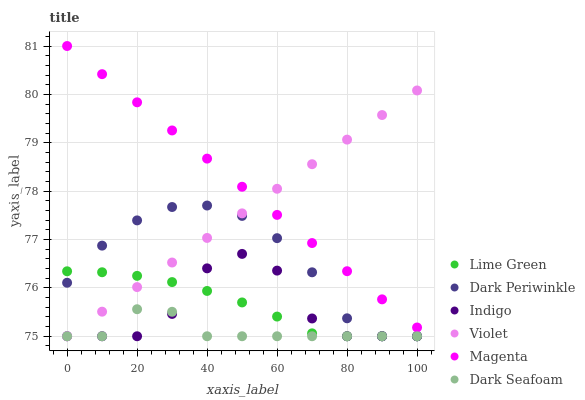Does Dark Seafoam have the minimum area under the curve?
Answer yes or no. Yes. Does Magenta have the maximum area under the curve?
Answer yes or no. Yes. Does Violet have the minimum area under the curve?
Answer yes or no. No. Does Violet have the maximum area under the curve?
Answer yes or no. No. Is Magenta the smoothest?
Answer yes or no. Yes. Is Indigo the roughest?
Answer yes or no. Yes. Is Dark Seafoam the smoothest?
Answer yes or no. No. Is Dark Seafoam the roughest?
Answer yes or no. No. Does Indigo have the lowest value?
Answer yes or no. Yes. Does Magenta have the lowest value?
Answer yes or no. No. Does Magenta have the highest value?
Answer yes or no. Yes. Does Violet have the highest value?
Answer yes or no. No. Is Indigo less than Magenta?
Answer yes or no. Yes. Is Magenta greater than Dark Periwinkle?
Answer yes or no. Yes. Does Violet intersect Indigo?
Answer yes or no. Yes. Is Violet less than Indigo?
Answer yes or no. No. Is Violet greater than Indigo?
Answer yes or no. No. Does Indigo intersect Magenta?
Answer yes or no. No. 